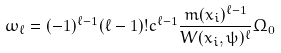<formula> <loc_0><loc_0><loc_500><loc_500>\omega _ { \ell } = ( - 1 ) ^ { \ell - 1 } ( \ell - 1 ) ! c ^ { \ell - 1 } \frac { m ( x _ { i } ) ^ { \ell - 1 } } { W ( x _ { i } , \psi ) ^ { \ell } } \Omega _ { 0 }</formula> 